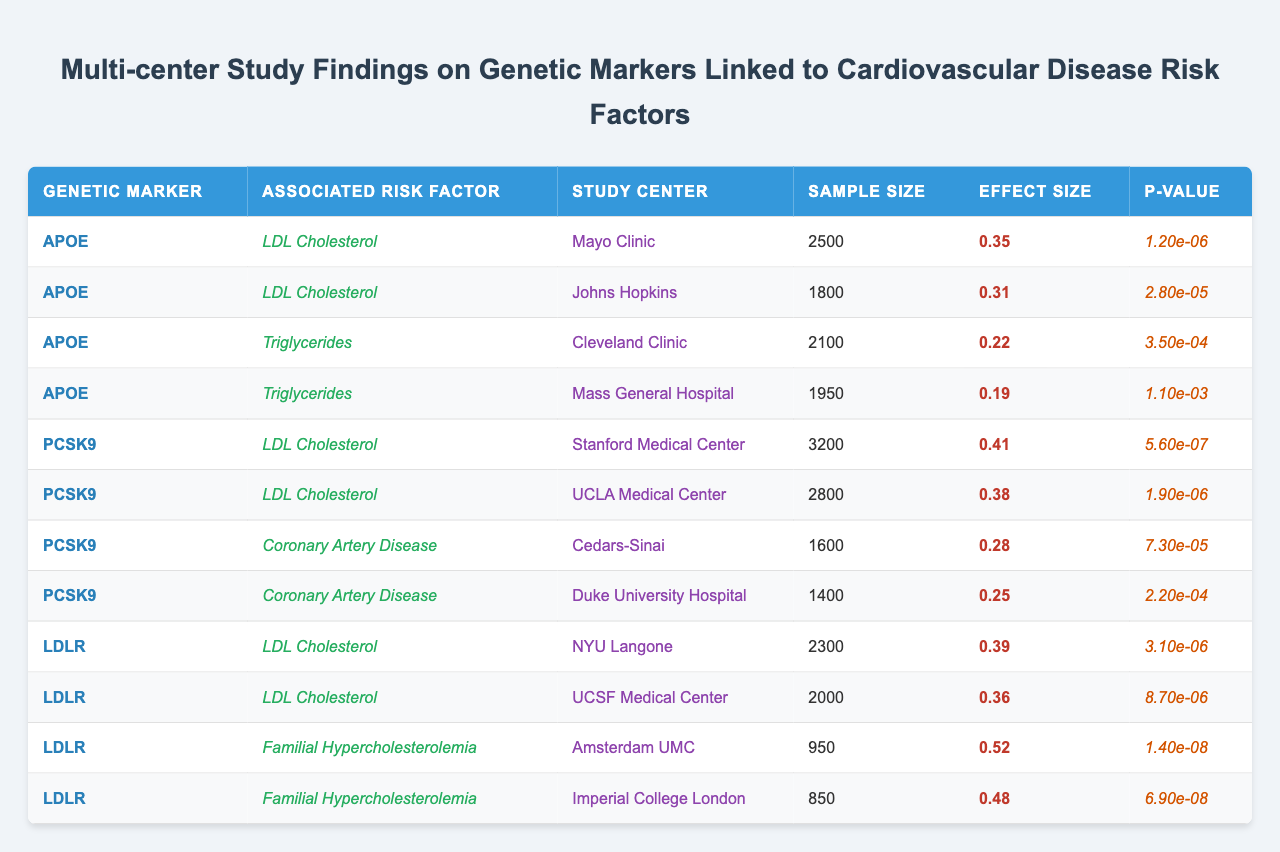What genetic marker shows the highest effect size associated with LDL Cholesterol? By examining the table, the genetic markers associated with LDL Cholesterol are APOE (0.35), PCSK9 (0.41), and LDLR (0.39). The highest value among these is for the PCSK9 marker with an effect size of 0.41.
Answer: PCSK9 Which study center reported the smallest sample size? Reviewing the table, the study centers listed along with their sample sizes are as follows: Mayo Clinic (2500), Johns Hopkins (1800), Cleveland Clinic (2100), Mass General Hospital (1950), Stanford Medical Center (3200), UCLA Medical Center (2800), NYU Langone (2300), UCSF Medical Center (2000), Amsterdam UMC (950), and Imperial College London (850). The smallest sample size is at Imperial College London with a sample size of 850.
Answer: 850 What is the average effect size of the genetic markers associated with Triglycerides? The effect sizes associated with Triglycerides come from the Cleveland Clinic (0.22) and Mass General Hospital (0.19). The average is calculated as (0.22 + 0.19) / 2 = 0.205.
Answer: 0.205 Is there any evidence indicating a significant association between the LDLR marker and Familial Hypercholesterolemia? The table indicates that the LDLR marker is associated with Familial Hypercholesterolemia, reporting an effect size of 0.52 and a P-value of 1.4e-8. Given that the P-value is much lower than the usual significance threshold of 0.05, we can affirm that there is significant evidence of association.
Answer: Yes Which risk factor has the largest effect size across all markers? The largest effect size overall in the table is for Familial Hypercholesterolemia linked to the LDLR marker with an effect size of 0.52, which is higher than any other listed risk factor.
Answer: Familial Hypercholesterolemia Which two study centers had the lowest effect size for LDL Cholesterol? From the entries for LDL Cholesterol: Mayo Clinic (0.35), Johns Hopkins (0.31), Stanford Medical Center (0.41), UCLA Medical Center (0.38), NYU Langone (0.39), UCSF Medical Center (0.36). The two lowest effect sizes belong to Johns Hopkins (0.31) and Mayo Clinic (0.35).
Answer: Johns Hopkins and Mayo Clinic What is the difference in effect size between PCSK9's LDL Cholesterol and its Coronary Artery Disease associations? The effect size for PCSK9 related to LDL Cholesterol is 0.41 and for Coronary Artery Disease is 0.28. The difference is calculated as 0.41 - 0.28 = 0.13.
Answer: 0.13 How many study centers reported on the associated risk factors for LDL Cholesterol? The risk factor LDL Cholesterol is represented in the table by four different study centers: Mayo Clinic, Johns Hopkins, Stanford Medical Center, and UCLA Medical Center. Thus, a total of four centers reported on this specific risk factor.
Answer: 4 What percentage of study centers showed an effect size greater than 0.30 for the LDL Cholesterol risk factor? The centers reporting effect sizes greater than 0.30 for LDL Cholesterol are Mayo Clinic (0.35), Johns Hopkins (0.31), Stanford Medical Center (0.41), and UCLA Medical Center (0.38), which is 4 out of 6 centers total (including NYU Langone and UCSF Medical Center). The percentage is calculated as (4/6) * 100 = 66.67%.
Answer: 66.67% 